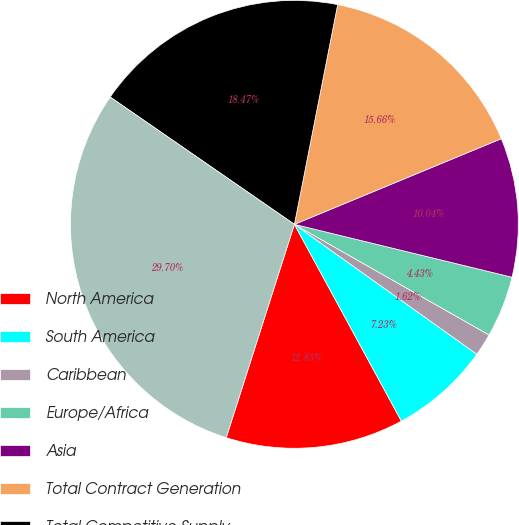<chart> <loc_0><loc_0><loc_500><loc_500><pie_chart><fcel>North America<fcel>South America<fcel>Caribbean<fcel>Europe/Africa<fcel>Asia<fcel>Total Contract Generation<fcel>Total Competitive Supply<fcel>Total Non-Regulated Revenues<nl><fcel>12.85%<fcel>7.23%<fcel>1.62%<fcel>4.43%<fcel>10.04%<fcel>15.66%<fcel>18.47%<fcel>29.7%<nl></chart> 